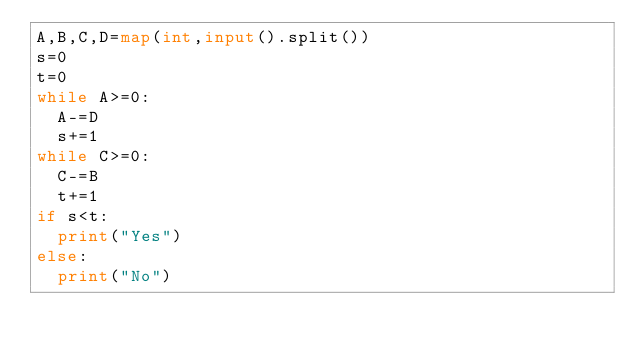Convert code to text. <code><loc_0><loc_0><loc_500><loc_500><_Python_>A,B,C,D=map(int,input().split())
s=0
t=0
while A>=0:
  A-=D
  s+=1
while C>=0:
  C-=B
  t+=1
if s<t:
  print("Yes")
else:
  print("No")</code> 